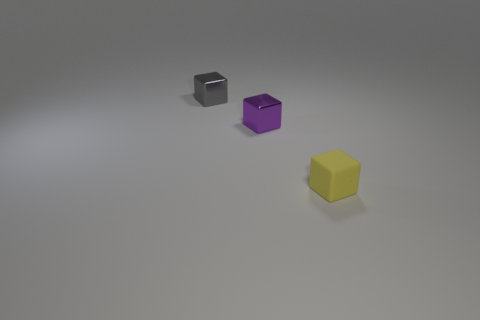Add 1 small purple shiny things. How many objects exist? 4 Subtract 0 gray balls. How many objects are left? 3 Subtract all matte cubes. Subtract all tiny yellow matte things. How many objects are left? 1 Add 1 purple things. How many purple things are left? 2 Add 1 big cyan rubber objects. How many big cyan rubber objects exist? 1 